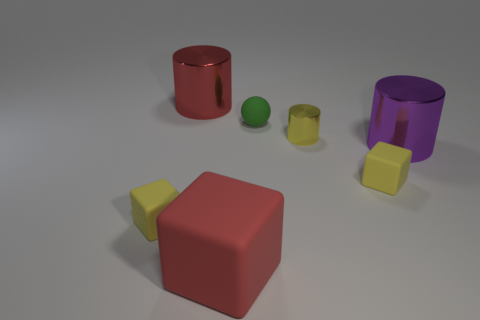Subtract all red cubes. How many cubes are left? 2 Subtract all red blocks. How many blocks are left? 2 Subtract all cylinders. How many objects are left? 4 Subtract 2 cubes. How many cubes are left? 1 Add 2 large things. How many large things exist? 5 Add 1 big rubber things. How many objects exist? 8 Subtract 0 brown balls. How many objects are left? 7 Subtract all brown spheres. Subtract all yellow cylinders. How many spheres are left? 1 Subtract all cyan cylinders. How many blue cubes are left? 0 Subtract all small blocks. Subtract all large cubes. How many objects are left? 4 